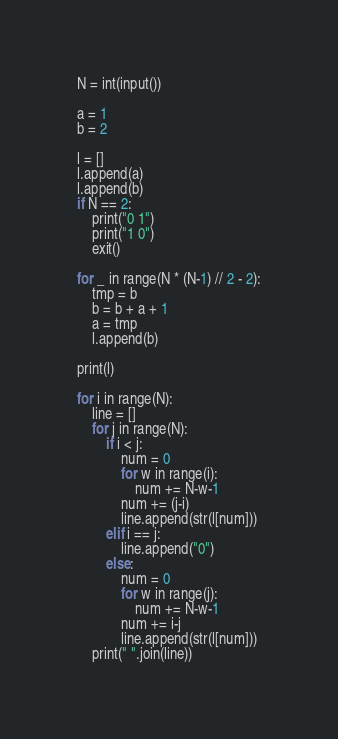<code> <loc_0><loc_0><loc_500><loc_500><_Python_>N = int(input())

a = 1
b = 2

l = []
l.append(a)
l.append(b)
if N == 2:
    print("0 1")
    print("1 0")
    exit()

for _ in range(N * (N-1) // 2 - 2):
    tmp = b
    b = b + a + 1
    a = tmp
    l.append(b)

print(l)

for i in range(N):
    line = []
    for j in range(N):
        if i < j:
            num = 0
            for w in range(i):
                num += N-w-1
            num += (j-i)
            line.append(str(l[num]))
        elif i == j:
            line.append("0")
        else:
            num = 0
            for w in range(j):
                num += N-w-1
            num += i-j
            line.append(str(l[num]))
    print(" ".join(line))
</code> 